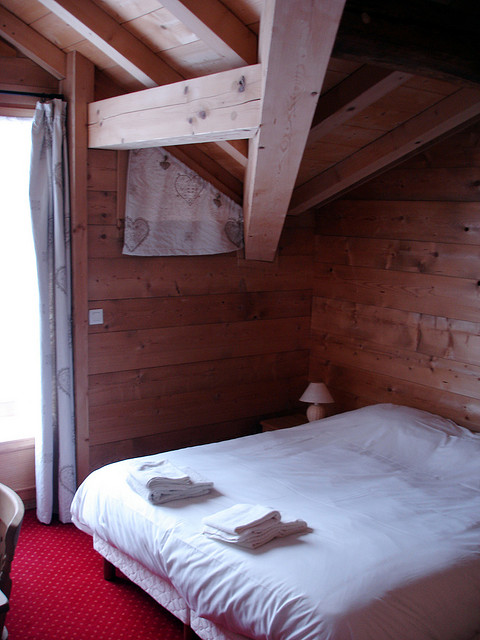<image>What type of fence is in the yard? It is ambiguous what type of fence is in the yard as it could be a wooden fence or no fence at all. What type of fence is in the yard? There is a wooden fence in the yard. 